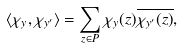<formula> <loc_0><loc_0><loc_500><loc_500>\langle \chi _ { y } , \chi _ { y ^ { \prime } } \rangle = \sum _ { z \in P } \chi _ { y } ( z ) \overline { \chi _ { y ^ { \prime } } ( z ) } ,</formula> 